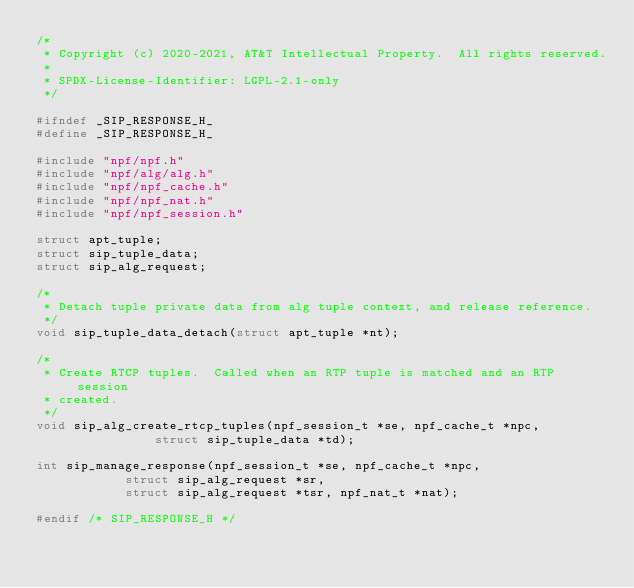Convert code to text. <code><loc_0><loc_0><loc_500><loc_500><_C_>/*
 * Copyright (c) 2020-2021, AT&T Intellectual Property.  All rights reserved.
 *
 * SPDX-License-Identifier: LGPL-2.1-only
 */

#ifndef _SIP_RESPONSE_H_
#define _SIP_RESPONSE_H_

#include "npf/npf.h"
#include "npf/alg/alg.h"
#include "npf/npf_cache.h"
#include "npf/npf_nat.h"
#include "npf/npf_session.h"

struct apt_tuple;
struct sip_tuple_data;
struct sip_alg_request;

/*
 * Detach tuple private data from alg tuple context, and release reference.
 */
void sip_tuple_data_detach(struct apt_tuple *nt);

/*
 * Create RTCP tuples.  Called when an RTP tuple is matched and an RTP session
 * created.
 */
void sip_alg_create_rtcp_tuples(npf_session_t *se, npf_cache_t *npc,
				struct sip_tuple_data *td);

int sip_manage_response(npf_session_t *se, npf_cache_t *npc,
			struct sip_alg_request *sr,
			struct sip_alg_request *tsr, npf_nat_t *nat);

#endif /* SIP_RESPONSE_H */
</code> 